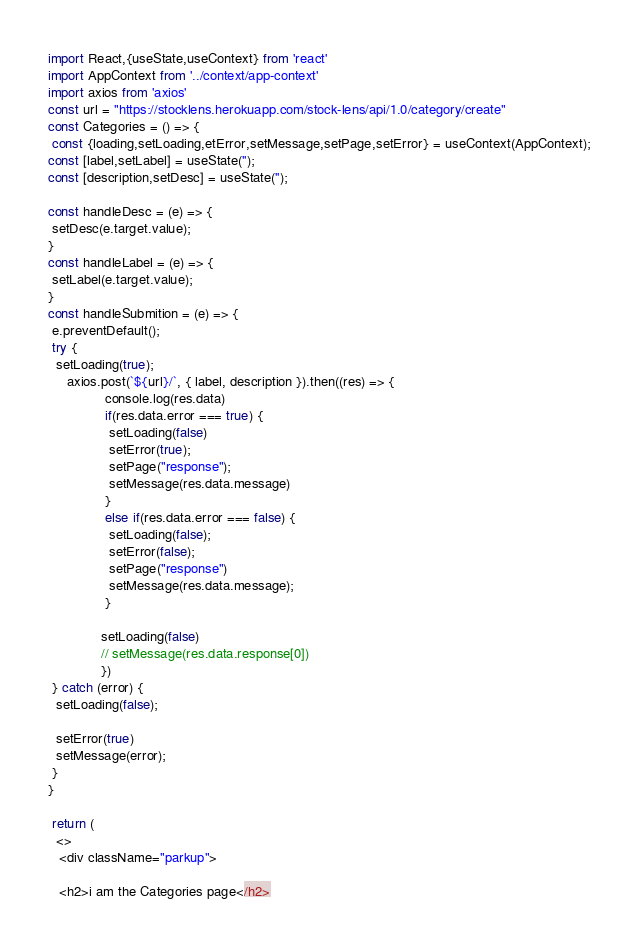<code> <loc_0><loc_0><loc_500><loc_500><_JavaScript_>import React,{useState,useContext} from 'react'
import AppContext from '../context/app-context'
import axios from 'axios'
const url = "https://stocklens.herokuapp.com/stock-lens/api/1.0/category/create"
const Categories = () => {
 const {loading,setLoading,etError,setMessage,setPage,setError} = useContext(AppContext);
const [label,setLabel] = useState('');
const [description,setDesc] = useState('');

const handleDesc = (e) => {
 setDesc(e.target.value);
}
const handleLabel = (e) => {
 setLabel(e.target.value);
}
const handleSubmition = (e) => {
 e.preventDefault();
 try {
  setLoading(true);
     axios.post(`${url}/`, { label, description }).then((res) => {
               console.log(res.data)
               if(res.data.error === true) {
                setLoading(false) 
                setError(true);
                setPage("response");
                setMessage(res.data.message)
               }
               else if(res.data.error === false) {
                setLoading(false);
                setError(false);
                setPage("response")
                setMessage(res.data.message);
               }
              
              setLoading(false) 
              // setMessage(res.data.response[0])
              })
 } catch (error) {
  setLoading(false);

  setError(true)
  setMessage(error);
 }
}

 return (
  <>
   <div className="parkup">
  
   <h2>i am the Categories page</h2></code> 